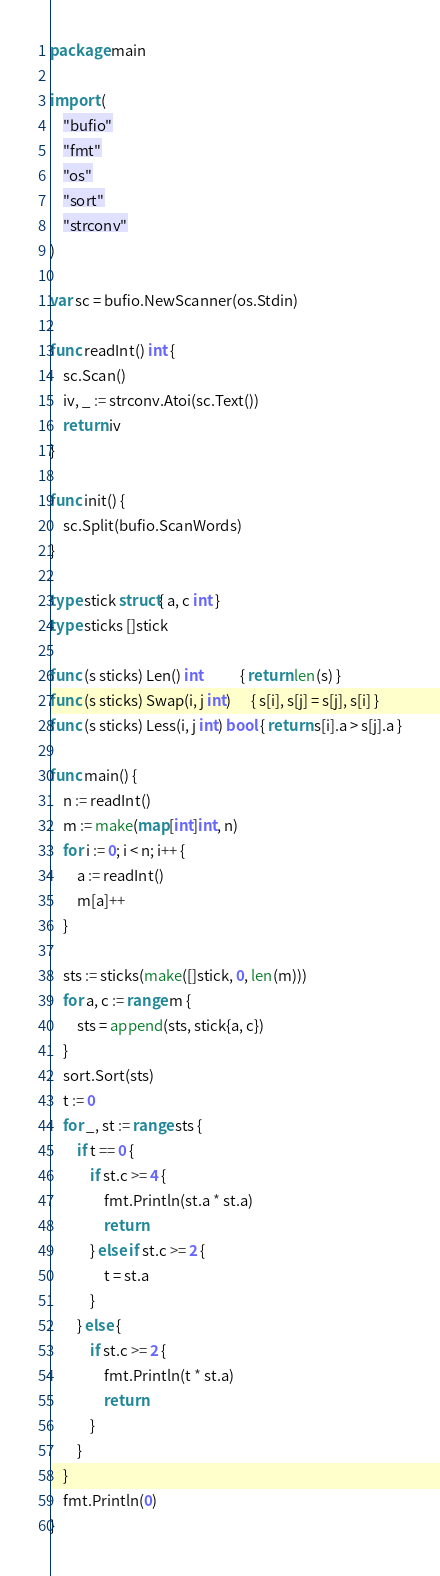Convert code to text. <code><loc_0><loc_0><loc_500><loc_500><_Go_>package main

import (
	"bufio"
	"fmt"
	"os"
	"sort"
	"strconv"
)

var sc = bufio.NewScanner(os.Stdin)

func readInt() int {
	sc.Scan()
	iv, _ := strconv.Atoi(sc.Text())
	return iv
}

func init() {
	sc.Split(bufio.ScanWords)
}

type stick struct{ a, c int }
type sticks []stick

func (s sticks) Len() int           { return len(s) }
func (s sticks) Swap(i, j int)      { s[i], s[j] = s[j], s[i] }
func (s sticks) Less(i, j int) bool { return s[i].a > s[j].a }

func main() {
	n := readInt()
	m := make(map[int]int, n)
	for i := 0; i < n; i++ {
		a := readInt()
		m[a]++
	}

	sts := sticks(make([]stick, 0, len(m)))
	for a, c := range m {
		sts = append(sts, stick{a, c})
	}
	sort.Sort(sts)
	t := 0
	for _, st := range sts {
		if t == 0 {
			if st.c >= 4 {
				fmt.Println(st.a * st.a)
				return
			} else if st.c >= 2 {
				t = st.a
			}
		} else {
			if st.c >= 2 {
				fmt.Println(t * st.a)
				return
			}
		}
	}
	fmt.Println(0)
}
</code> 